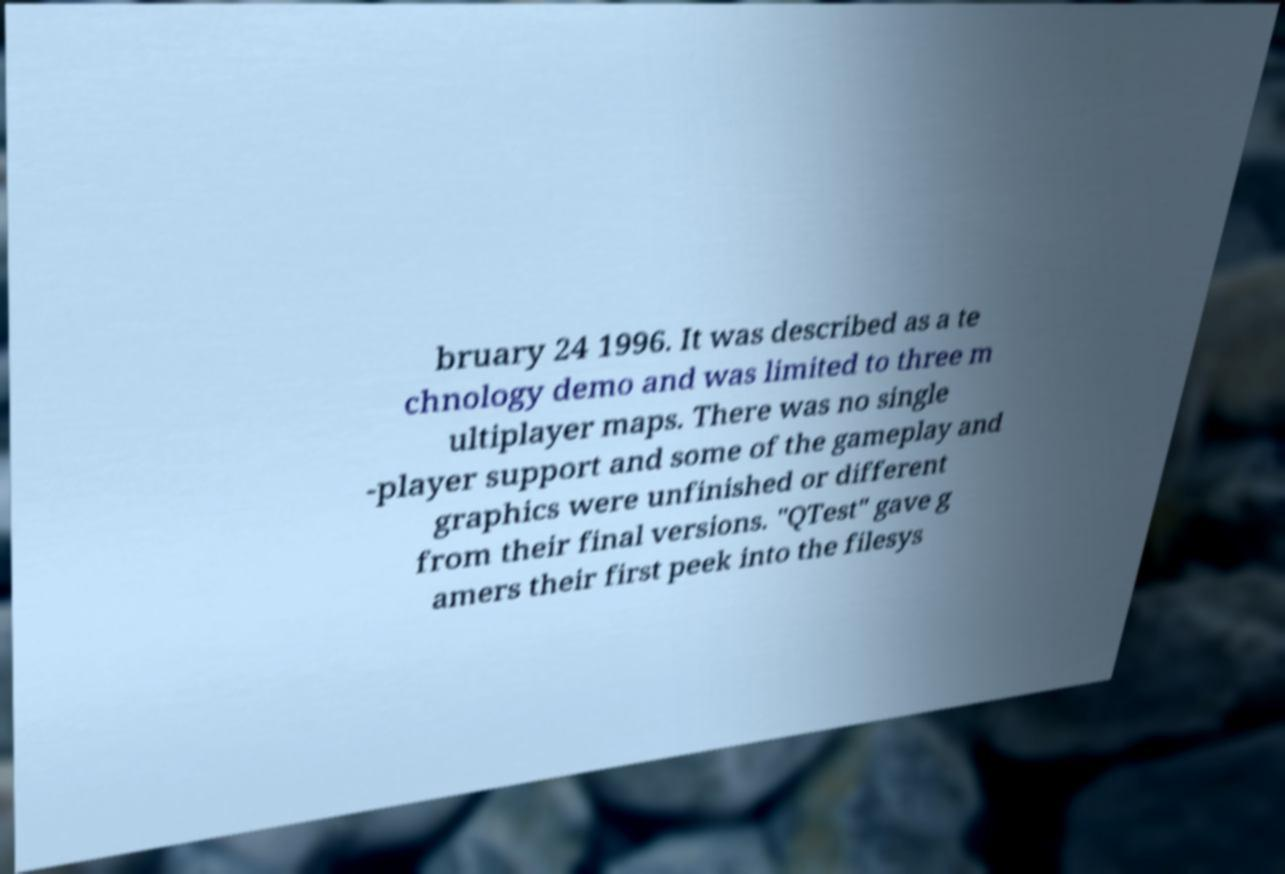Could you extract and type out the text from this image? bruary 24 1996. It was described as a te chnology demo and was limited to three m ultiplayer maps. There was no single -player support and some of the gameplay and graphics were unfinished or different from their final versions. "QTest" gave g amers their first peek into the filesys 